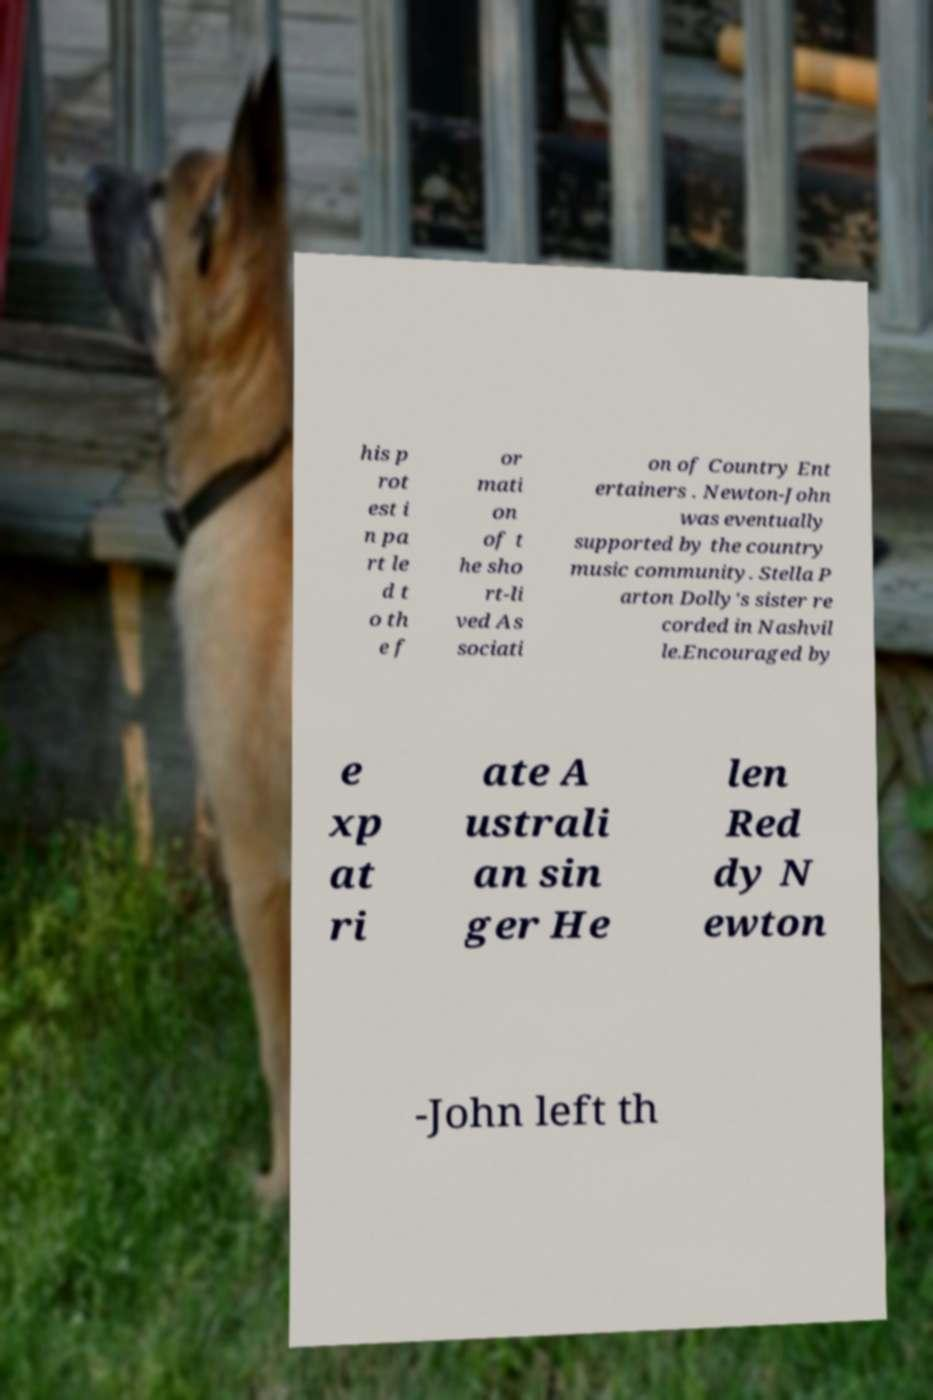Could you extract and type out the text from this image? his p rot est i n pa rt le d t o th e f or mati on of t he sho rt-li ved As sociati on of Country Ent ertainers . Newton-John was eventually supported by the country music community. Stella P arton Dolly's sister re corded in Nashvil le.Encouraged by e xp at ri ate A ustrali an sin ger He len Red dy N ewton -John left th 